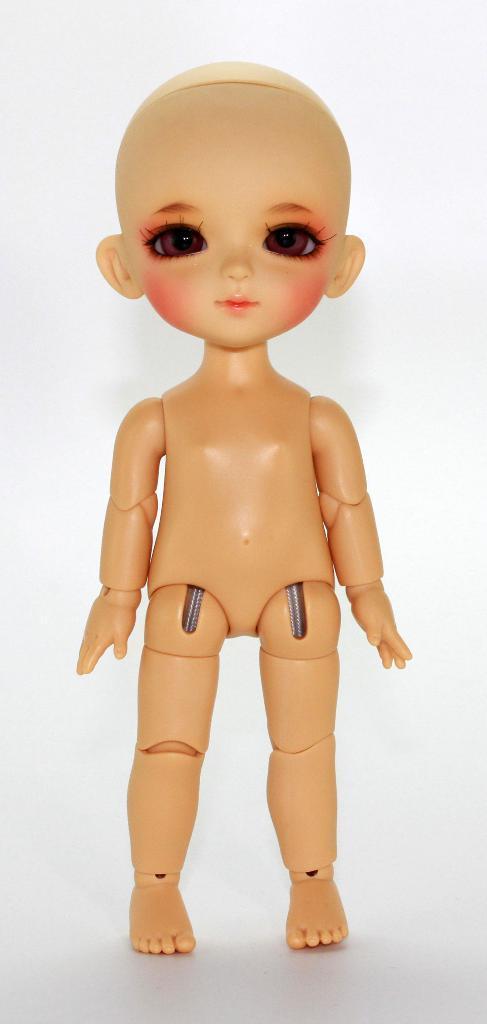How would you summarize this image in a sentence or two? In the center of the image there is a doll. The background of the image is white in color. 